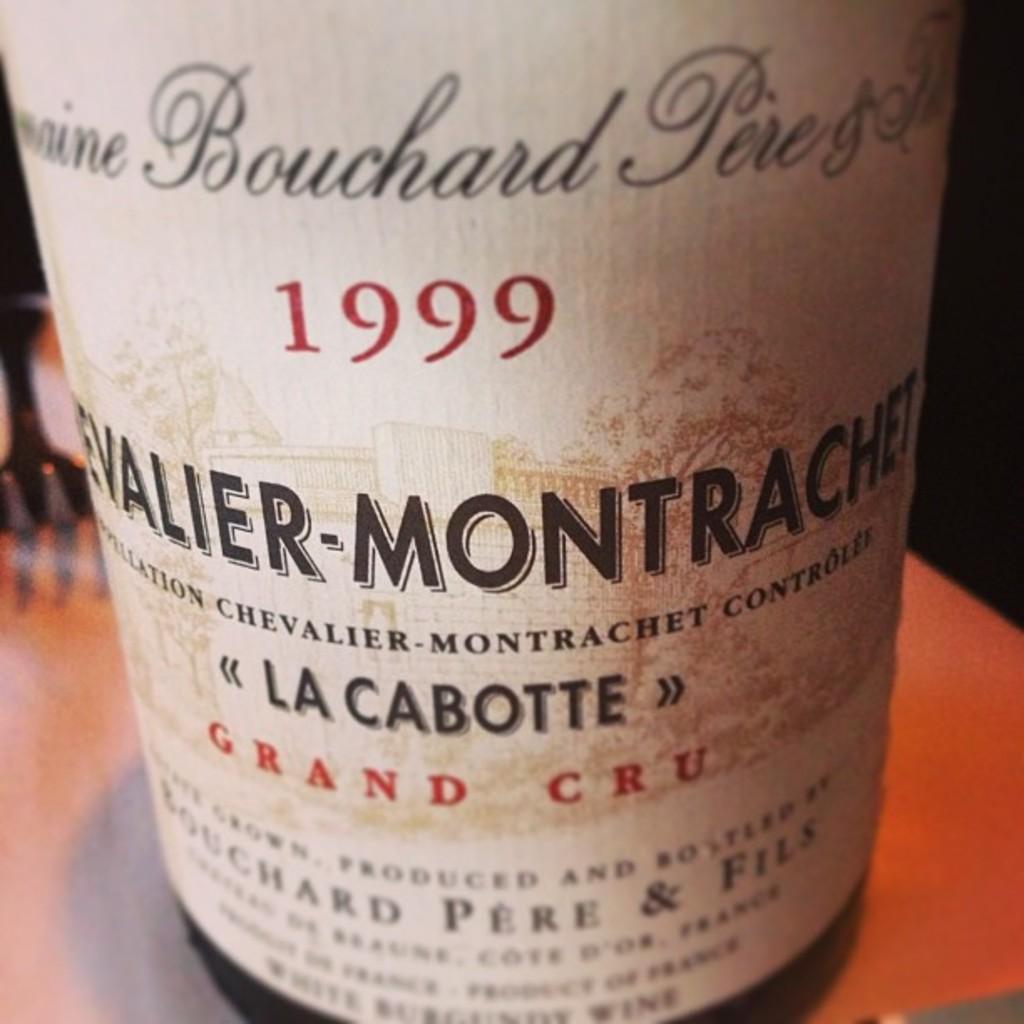What is the name for this wine?
Give a very brief answer. La cabotte. 